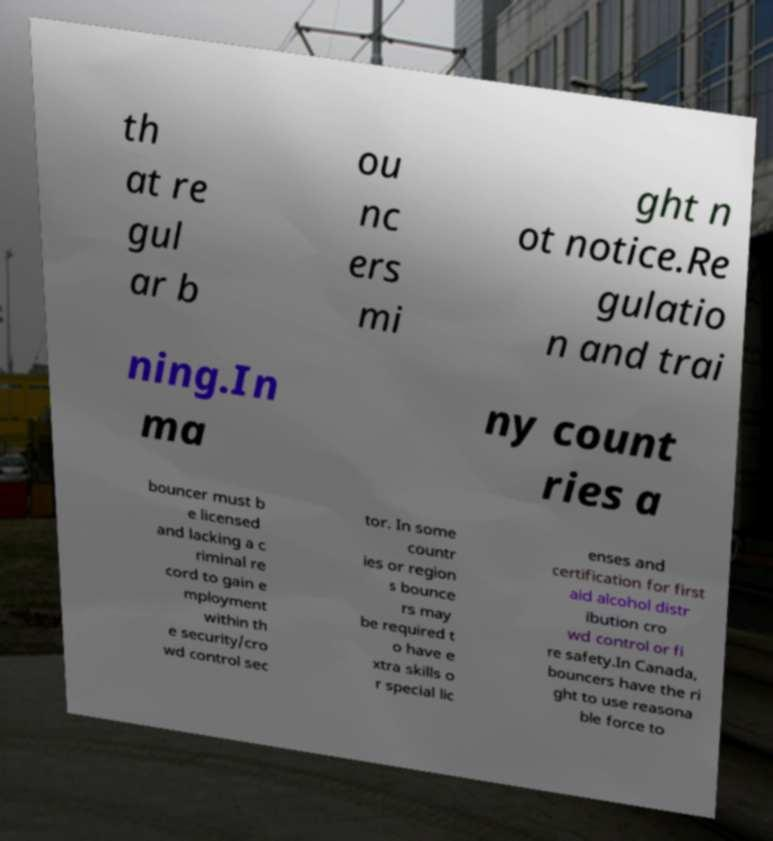There's text embedded in this image that I need extracted. Can you transcribe it verbatim? th at re gul ar b ou nc ers mi ght n ot notice.Re gulatio n and trai ning.In ma ny count ries a bouncer must b e licensed and lacking a c riminal re cord to gain e mployment within th e security/cro wd control sec tor. In some countr ies or region s bounce rs may be required t o have e xtra skills o r special lic enses and certification for first aid alcohol distr ibution cro wd control or fi re safety.In Canada, bouncers have the ri ght to use reasona ble force to 